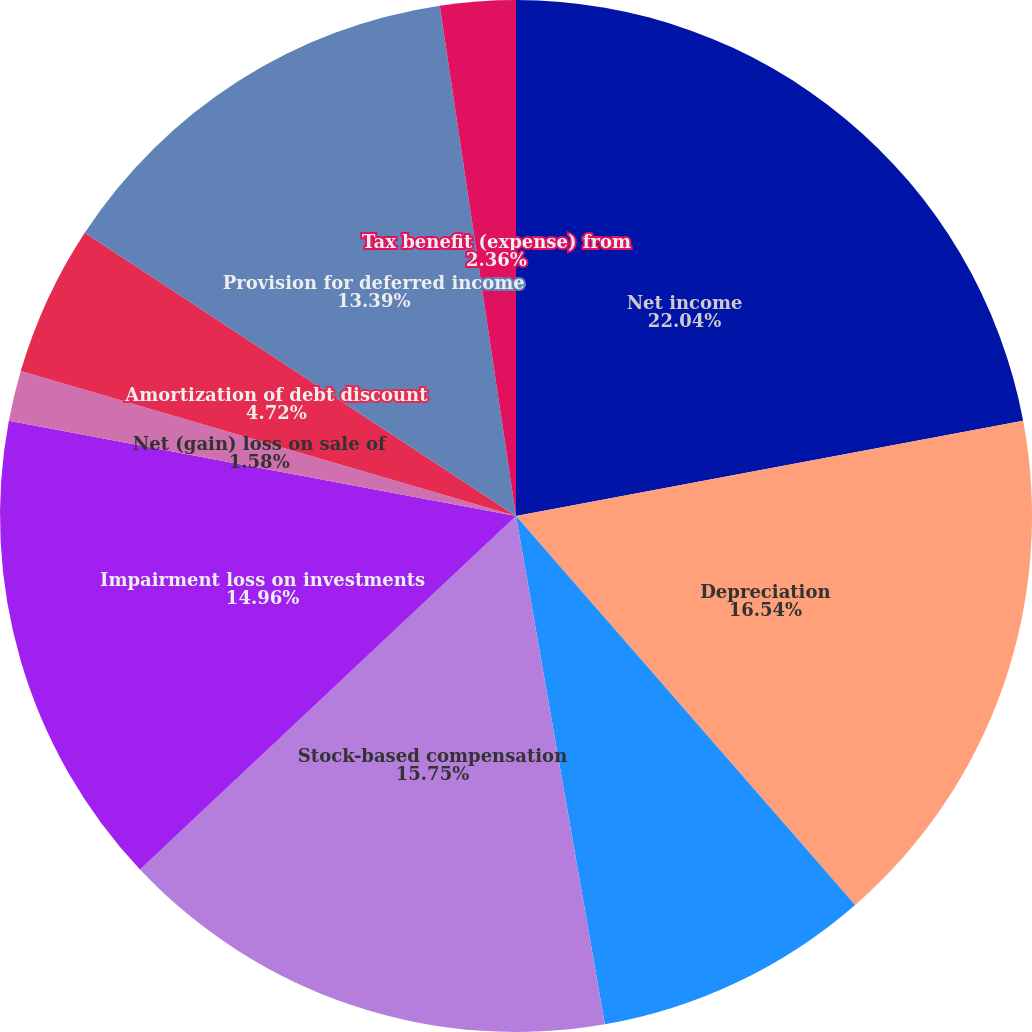Convert chart. <chart><loc_0><loc_0><loc_500><loc_500><pie_chart><fcel>Net income<fcel>Depreciation<fcel>Amortization<fcel>Stock-based compensation<fcel>Impairment loss on investments<fcel>Net (gain) loss on sale of<fcel>Amortization of debt discount<fcel>Convertible debt derivatives -<fcel>Provision for deferred income<fcel>Tax benefit (expense) from<nl><fcel>22.05%<fcel>16.54%<fcel>8.66%<fcel>15.75%<fcel>14.96%<fcel>1.58%<fcel>4.72%<fcel>0.0%<fcel>13.39%<fcel>2.36%<nl></chart> 